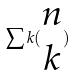<formula> <loc_0><loc_0><loc_500><loc_500>\sum k ( \begin{matrix} n \\ k \end{matrix} )</formula> 